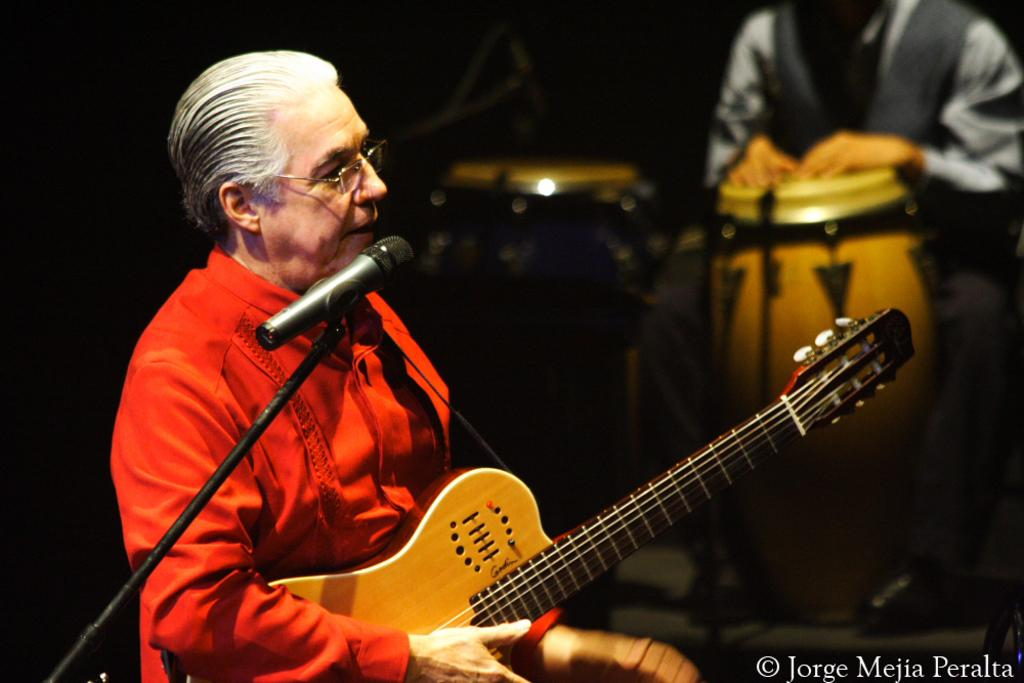What is the man in the image wearing? The man is wearing a red dress. What is the man doing in the image? The man is playing a guitar. What object is in front of the man? There is a microphone in front of the man. Are there any other people in the image? Yes, there is another man in the image. What instrument is the second man playing? The second man is playing a trumpet. What type of sugar is being used to sweeten the beds in the image? There are no beds or sugar present in the image; it features two men playing musical instruments. 